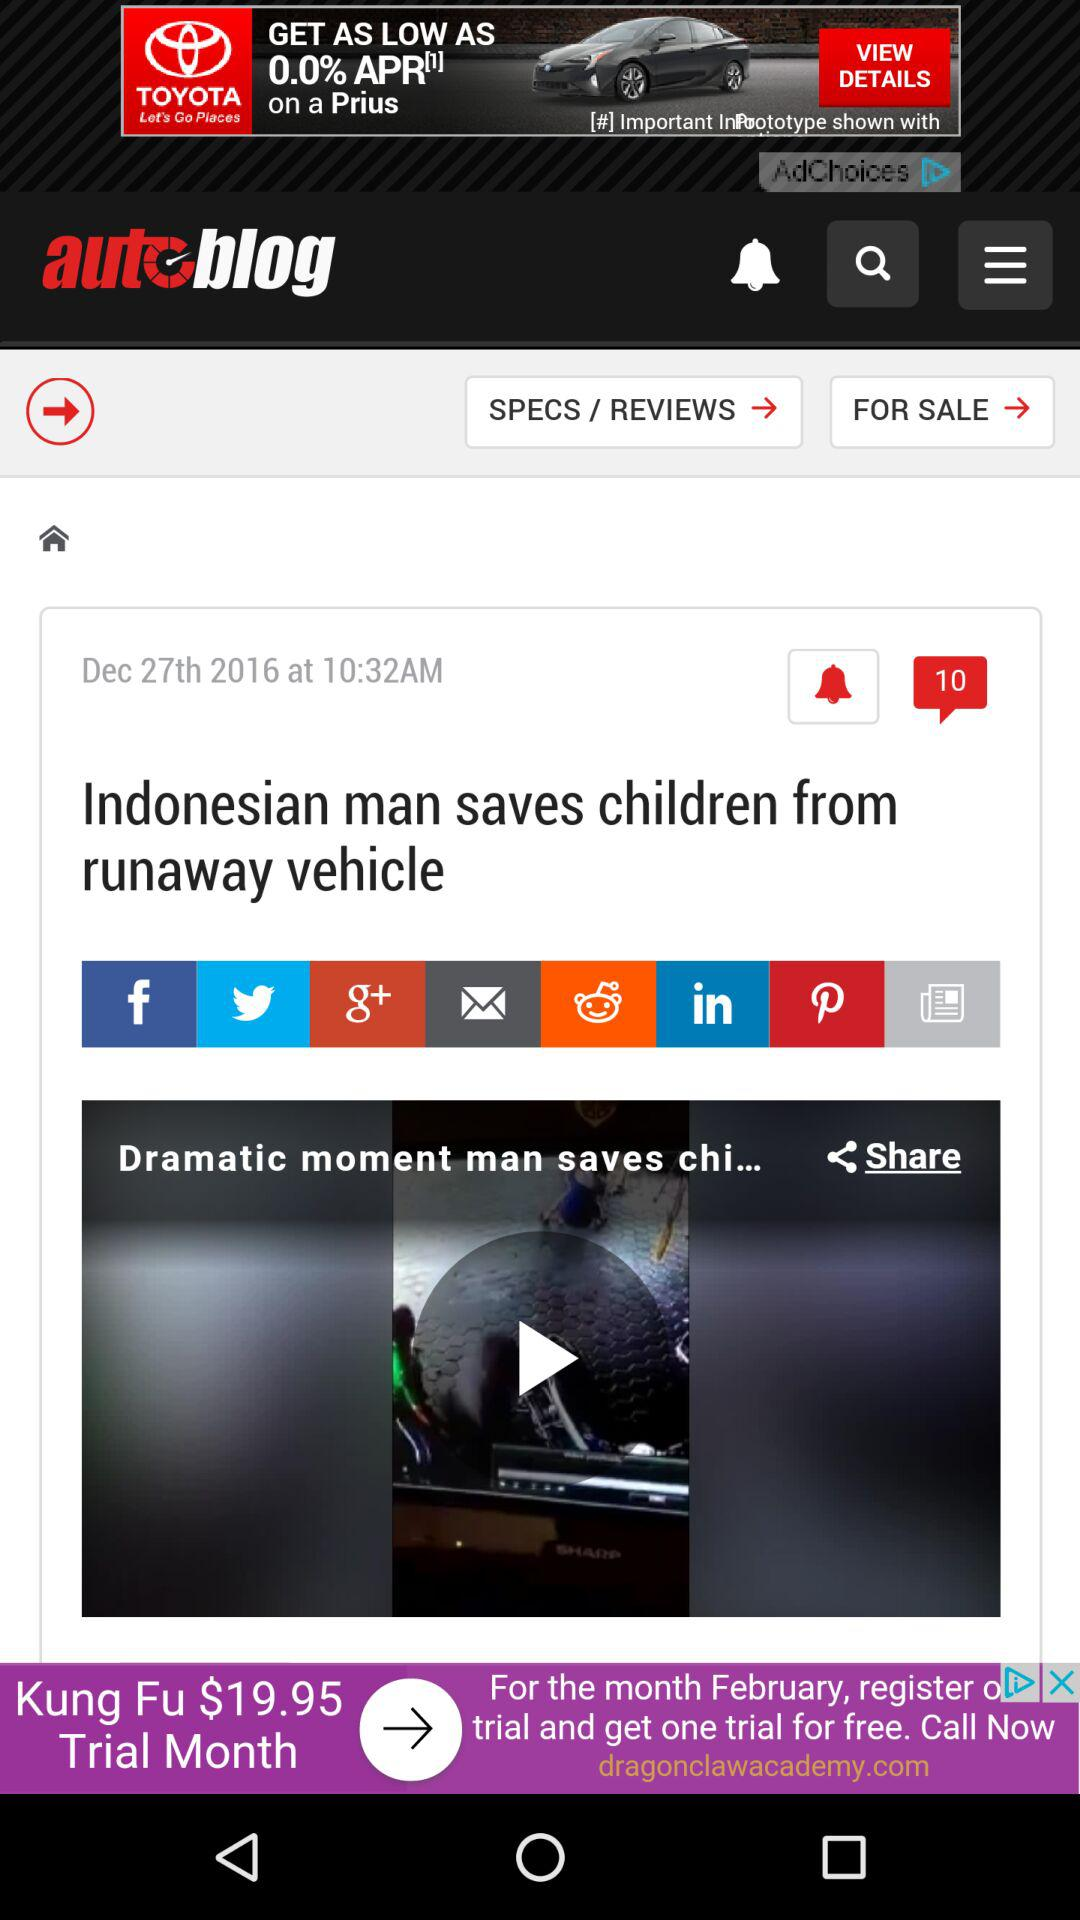What is the posted date of the article "Indonesian man saves children from runaway vehicle"? The posted date of the article "Indonesian man saves children from runaway vehicle" is December 27, 2016. 